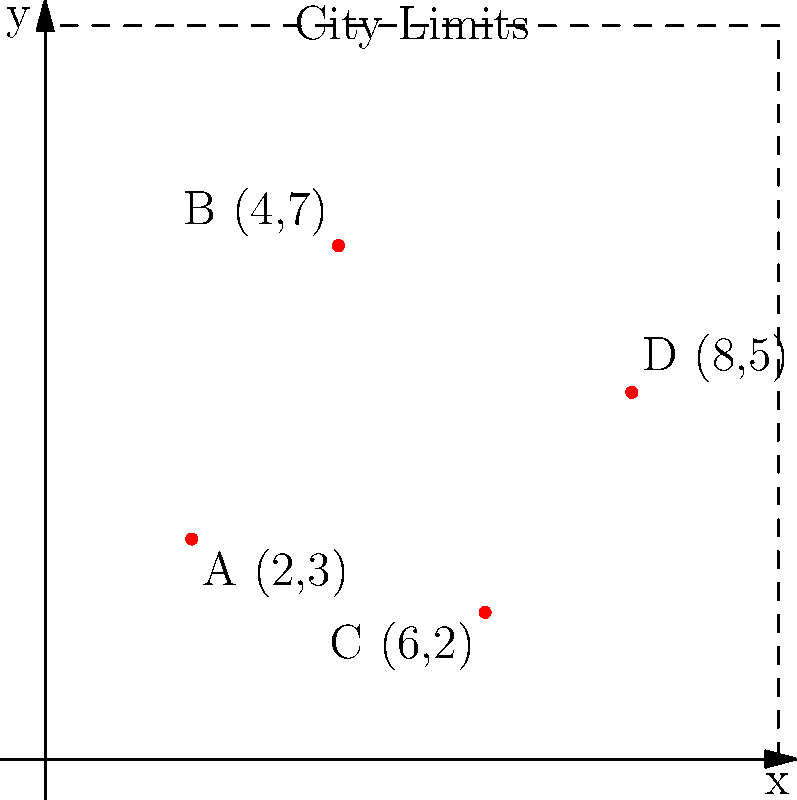The city map shows job opportunities for ex-convicts plotted on a coordinate system. Points A, B, C, and D represent different job locations. If a new job opportunity becomes available at coordinates (5,6), what would be the total number of job opportunities within the city limits? To solve this problem, let's follow these steps:

1. Count the existing job opportunities:
   - Point A: (2,3)
   - Point B: (4,7)
   - Point C: (6,2)
   - Point D: (8,5)
   There are 4 existing job opportunities.

2. Consider the new job opportunity:
   - New point: (5,6)
   This adds 1 more job opportunity.

3. Check if all points are within city limits:
   - The city limits are shown by the dashed line, which forms a square from (0,0) to (10,10).
   - All existing points (A, B, C, D) and the new point (5,6) fall within these boundaries.

4. Calculate the total number of job opportunities:
   $$ \text{Total} = \text{Existing opportunities} + \text{New opportunity} $$
   $$ \text{Total} = 4 + 1 = 5 $$

Therefore, with the addition of the new job opportunity at (5,6), there would be a total of 5 job opportunities within the city limits.
Answer: 5 job opportunities 